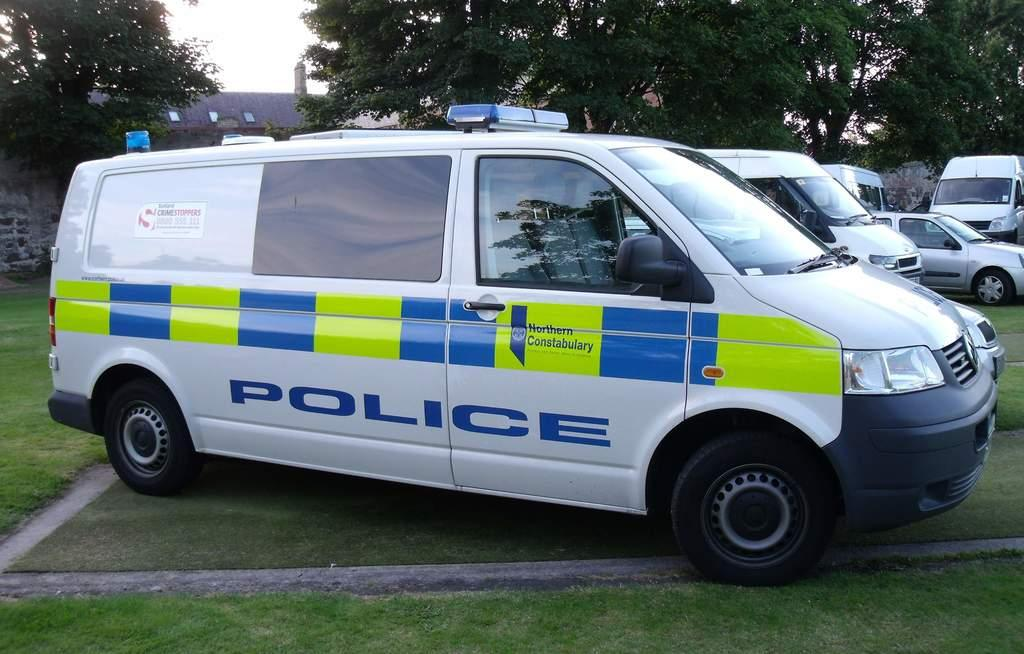<image>
Present a compact description of the photo's key features. a POLICE van from Northern Constabulary on a lawn 